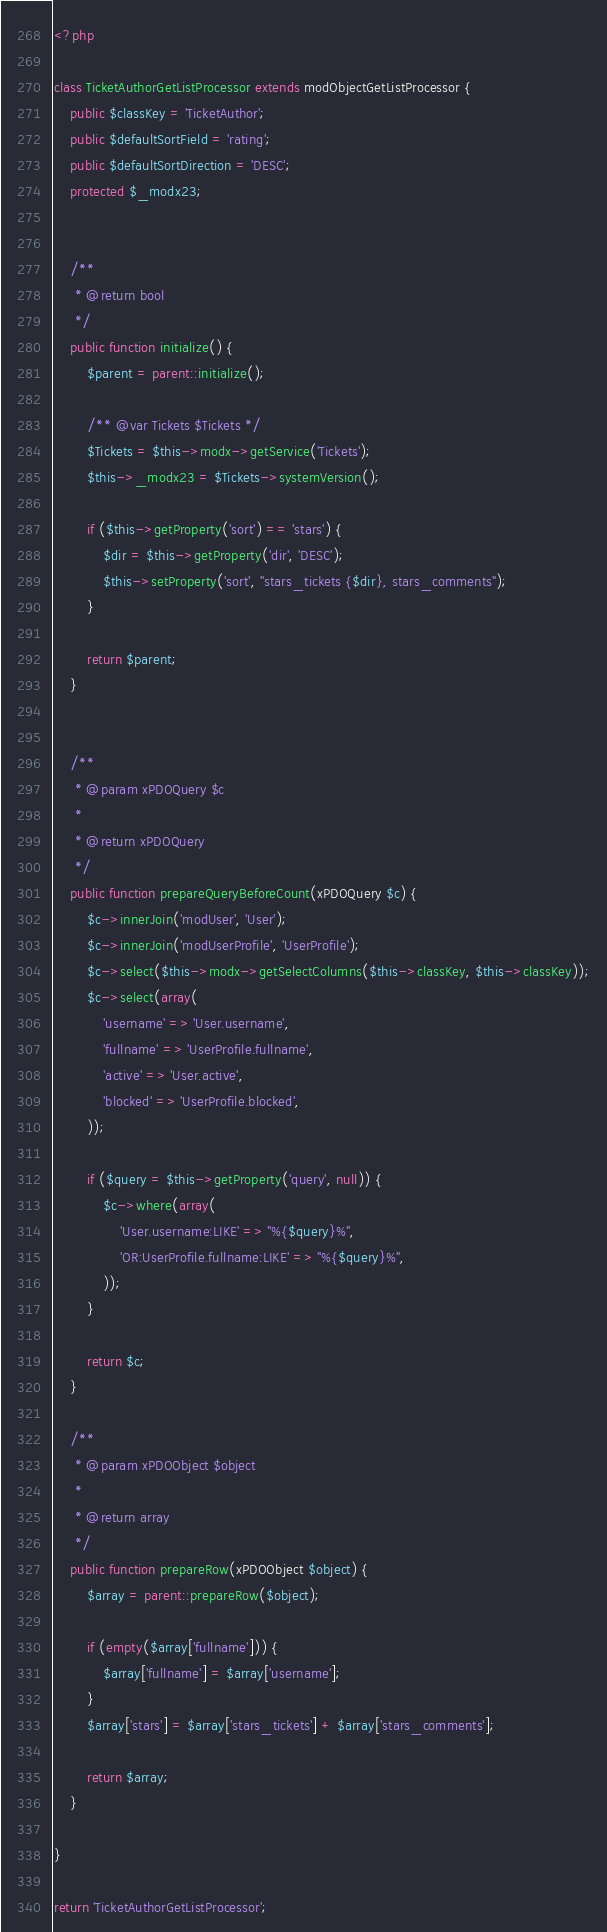<code> <loc_0><loc_0><loc_500><loc_500><_PHP_><?php

class TicketAuthorGetListProcessor extends modObjectGetListProcessor {
	public $classKey = 'TicketAuthor';
	public $defaultSortField = 'rating';
	public $defaultSortDirection = 'DESC';
	protected $_modx23;


	/**
	 * @return bool
	 */
	public function initialize() {
		$parent = parent::initialize();

		/** @var Tickets $Tickets */
		$Tickets = $this->modx->getService('Tickets');
		$this->_modx23 = $Tickets->systemVersion();

		if ($this->getProperty('sort') == 'stars') {
			$dir = $this->getProperty('dir', 'DESC');
			$this->setProperty('sort', "stars_tickets {$dir}, stars_comments");
		}

		return $parent;
	}


	/**
	 * @param xPDOQuery $c
	 *
	 * @return xPDOQuery
	 */
	public function prepareQueryBeforeCount(xPDOQuery $c) {
		$c->innerJoin('modUser', 'User');
		$c->innerJoin('modUserProfile', 'UserProfile');
		$c->select($this->modx->getSelectColumns($this->classKey, $this->classKey));
		$c->select(array(
			'username' => 'User.username',
			'fullname' => 'UserProfile.fullname',
			'active' => 'User.active',
			'blocked' => 'UserProfile.blocked',
		));

		if ($query = $this->getProperty('query', null)) {
			$c->where(array(
				'User.username:LIKE' => "%{$query}%",
				'OR:UserProfile.fullname:LIKE' => "%{$query}%",
			));
		}

		return $c;
	}

	/**
	 * @param xPDOObject $object
	 *
	 * @return array
	 */
	public function prepareRow(xPDOObject $object) {
		$array = parent::prepareRow($object);

		if (empty($array['fullname'])) {
			$array['fullname'] = $array['username'];
		}
		$array['stars'] = $array['stars_tickets'] + $array['stars_comments'];

		return $array;
	}

}

return 'TicketAuthorGetListProcessor';</code> 